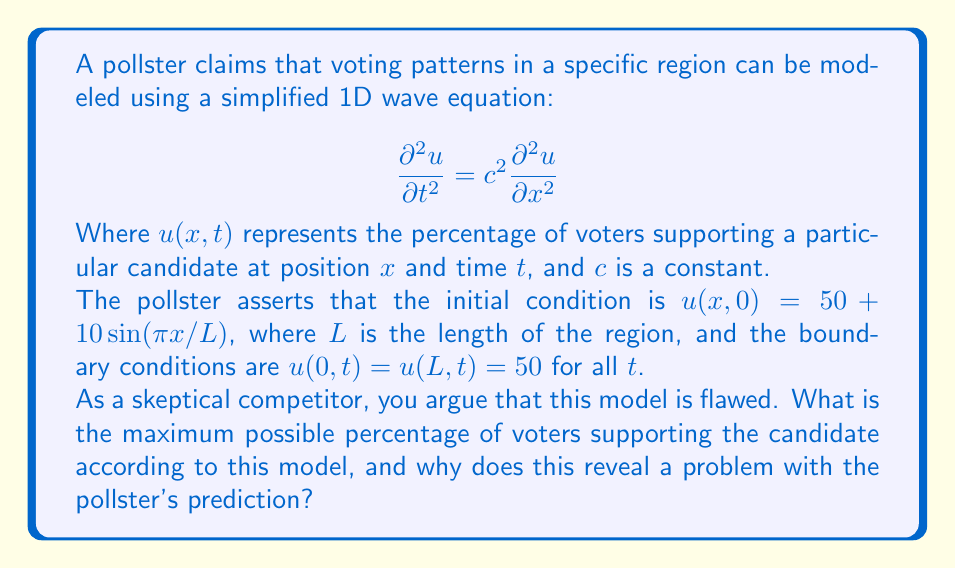Solve this math problem. Let's approach this step-by-step:

1) The general solution to the 1D wave equation with the given boundary conditions is:

   $$u(x,t) = 50 + \sum_{n=1}^{\infty} A_n \sin(\frac{n\pi x}{L}) \cos(\frac{n\pi c t}{L})$$

2) The initial condition is:

   $$u(x,0) = 50 + 10\sin(\pi x/L)$$

3) Comparing this with the general solution at $t=0$, we can see that:
   - $A_1 = 10$
   - $A_n = 0$ for all $n > 1$

4) Therefore, the complete solution is:

   $$u(x,t) = 50 + 10\sin(\frac{\pi x}{L}) \cos(\frac{\pi c t}{L})$$

5) To find the maximum value, we need to maximize both $\sin(\frac{\pi x}{L})$ and $\cos(\frac{\pi c t}{L})$:
   - $\sin(\frac{\pi x}{L})$ reaches its maximum of 1 when $x = L/2$
   - $\cos(\frac{\pi c t}{L})$ reaches its maximum of 1 when $t = 0$

6) Therefore, the maximum value is:

   $$u_{max} = 50 + 10 = 60$$

7) This reveals a problem with the pollster's prediction because:
   - The percentage of voters cannot exceed 100%
   - The model allows for values up to 60%, which is reasonable
   - However, it also allows for values as low as 40% (when the sine term is -1)
   - Percentages below 0% or above 100% are meaningless in the context of voting

This demonstrates that while the model may capture some oscillatory behavior, it fails to properly constrain the values to a realistic range for voting percentages.
Answer: 60% 